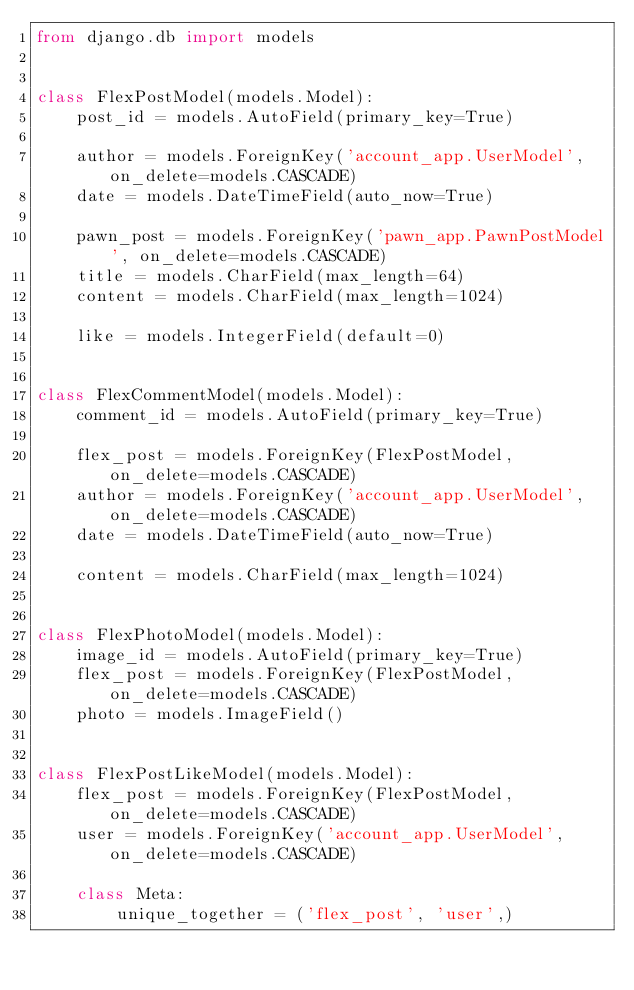Convert code to text. <code><loc_0><loc_0><loc_500><loc_500><_Python_>from django.db import models


class FlexPostModel(models.Model):
    post_id = models.AutoField(primary_key=True)

    author = models.ForeignKey('account_app.UserModel', on_delete=models.CASCADE)
    date = models.DateTimeField(auto_now=True)

    pawn_post = models.ForeignKey('pawn_app.PawnPostModel', on_delete=models.CASCADE)
    title = models.CharField(max_length=64)
    content = models.CharField(max_length=1024)

    like = models.IntegerField(default=0)


class FlexCommentModel(models.Model):
    comment_id = models.AutoField(primary_key=True)

    flex_post = models.ForeignKey(FlexPostModel, on_delete=models.CASCADE)
    author = models.ForeignKey('account_app.UserModel', on_delete=models.CASCADE)
    date = models.DateTimeField(auto_now=True)

    content = models.CharField(max_length=1024)


class FlexPhotoModel(models.Model):
    image_id = models.AutoField(primary_key=True)
    flex_post = models.ForeignKey(FlexPostModel, on_delete=models.CASCADE)
    photo = models.ImageField()


class FlexPostLikeModel(models.Model):
    flex_post = models.ForeignKey(FlexPostModel, on_delete=models.CASCADE)
    user = models.ForeignKey('account_app.UserModel', on_delete=models.CASCADE)

    class Meta:
        unique_together = ('flex_post', 'user',)
</code> 